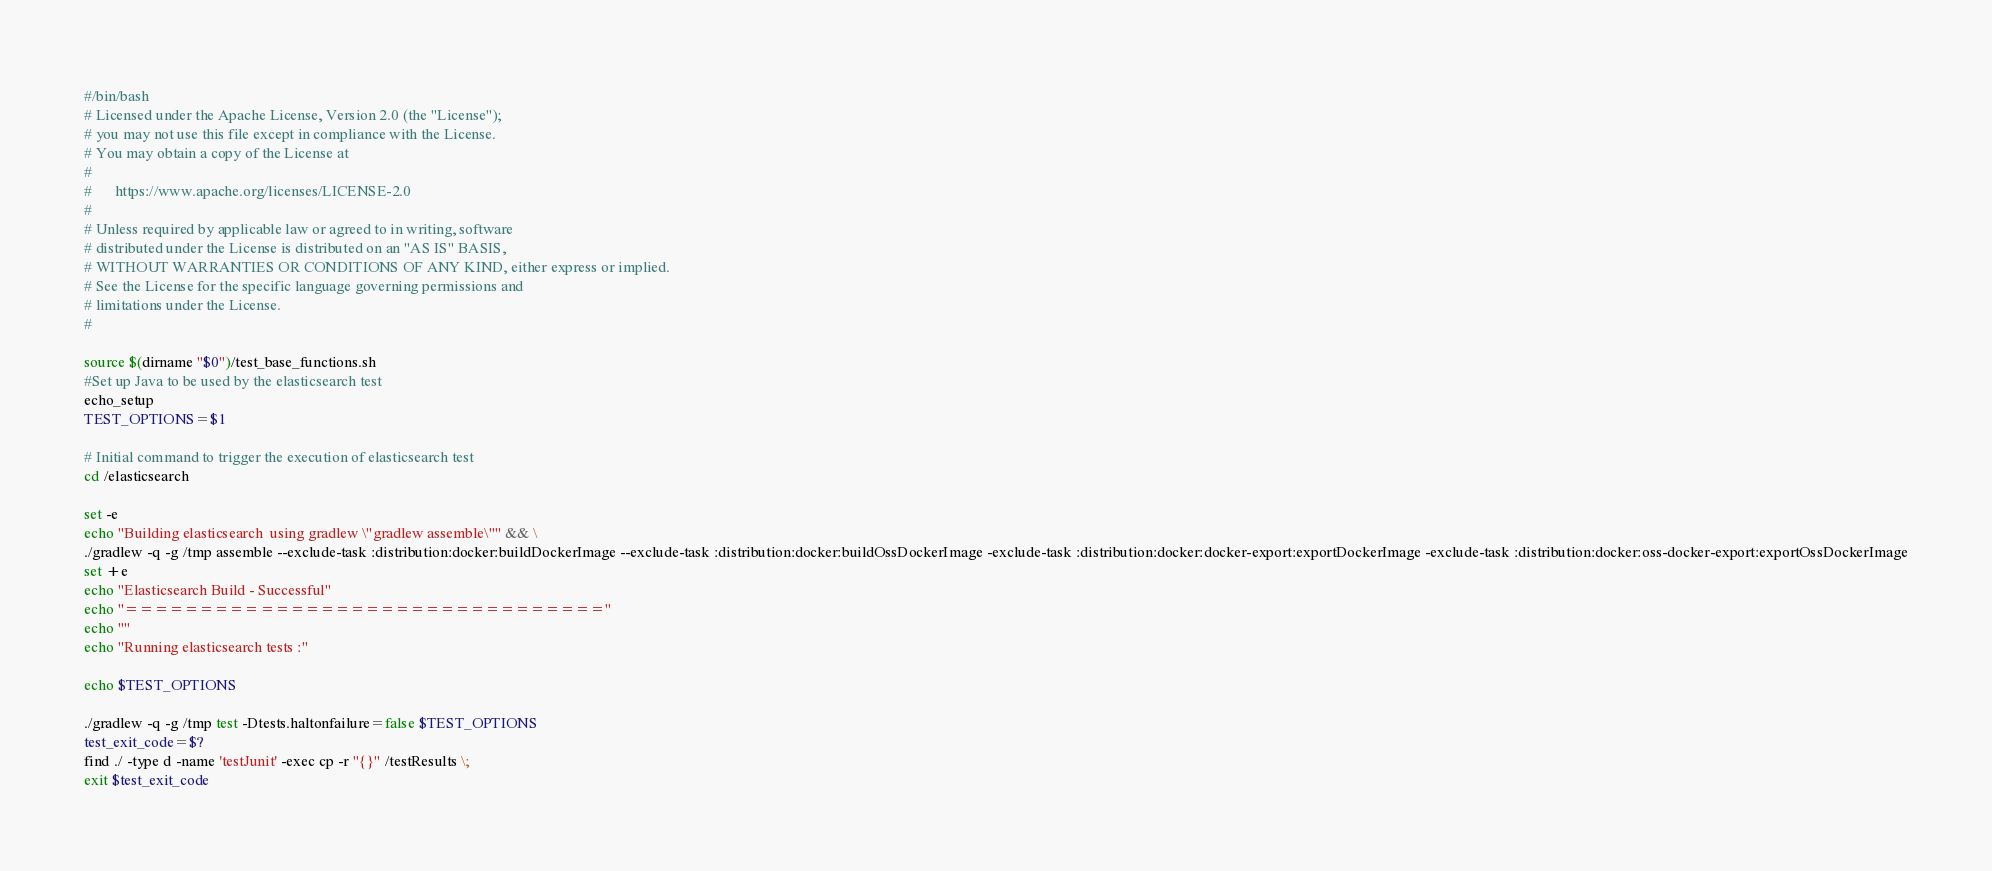Convert code to text. <code><loc_0><loc_0><loc_500><loc_500><_Bash_>#/bin/bash
# Licensed under the Apache License, Version 2.0 (the "License");
# you may not use this file except in compliance with the License.
# You may obtain a copy of the License at
#
#      https://www.apache.org/licenses/LICENSE-2.0
#
# Unless required by applicable law or agreed to in writing, software
# distributed under the License is distributed on an "AS IS" BASIS,
# WITHOUT WARRANTIES OR CONDITIONS OF ANY KIND, either express or implied.
# See the License for the specific language governing permissions and
# limitations under the License.
#

source $(dirname "$0")/test_base_functions.sh
#Set up Java to be used by the elasticsearch test
echo_setup
TEST_OPTIONS=$1

# Initial command to trigger the execution of elasticsearch test 
cd /elasticsearch

set -e
echo "Building elasticsearch  using gradlew \"gradlew assemble\"" && \
./gradlew -q -g /tmp assemble --exclude-task :distribution:docker:buildDockerImage --exclude-task :distribution:docker:buildOssDockerImage -exclude-task :distribution:docker:docker-export:exportDockerImage -exclude-task :distribution:docker:oss-docker-export:exportOssDockerImage
set +e
echo "Elasticsearch Build - Successful"
echo "================================"
echo ""
echo "Running elasticsearch tests :"

echo $TEST_OPTIONS

./gradlew -q -g /tmp test -Dtests.haltonfailure=false $TEST_OPTIONS
test_exit_code=$?
find ./ -type d -name 'testJunit' -exec cp -r "{}" /testResults \;
exit $test_exit_code
</code> 